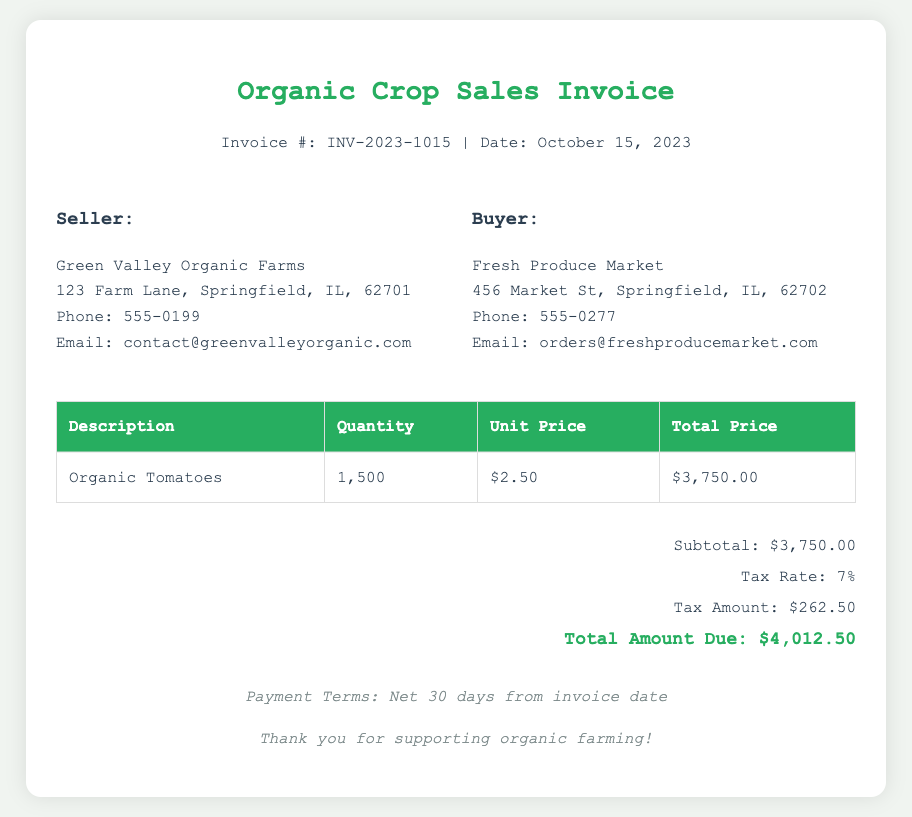What is the invoice number? The invoice number is clearly mentioned in the header of the document.
Answer: INV-2023-1015 What is the total quantity of organic tomatoes sold? The quantity sold is specified in the table under the quantity column.
Answer: 1,500 What is the unit price for organic tomatoes? The unit price is found in the table next to the organic tomatoes.
Answer: $2.50 What is the subtotal amount due? The subtotal is listed in the summary section of the document.
Answer: $3,750.00 What is the tax rate applied to the sale? The tax rate is stated in the summary section.
Answer: 7% What is the total amount due? The total amount due is the final figure listed in the summary section.
Answer: $4,012.50 Who is the seller? The seller's name is found in the seller details section.
Answer: Green Valley Organic Farms What are the payment terms? The payment terms are noted at the bottom of the invoice.
Answer: Net 30 days from invoice date Who is the buyer? The buyer's name is included in the buyer details section.
Answer: Fresh Produce Market 